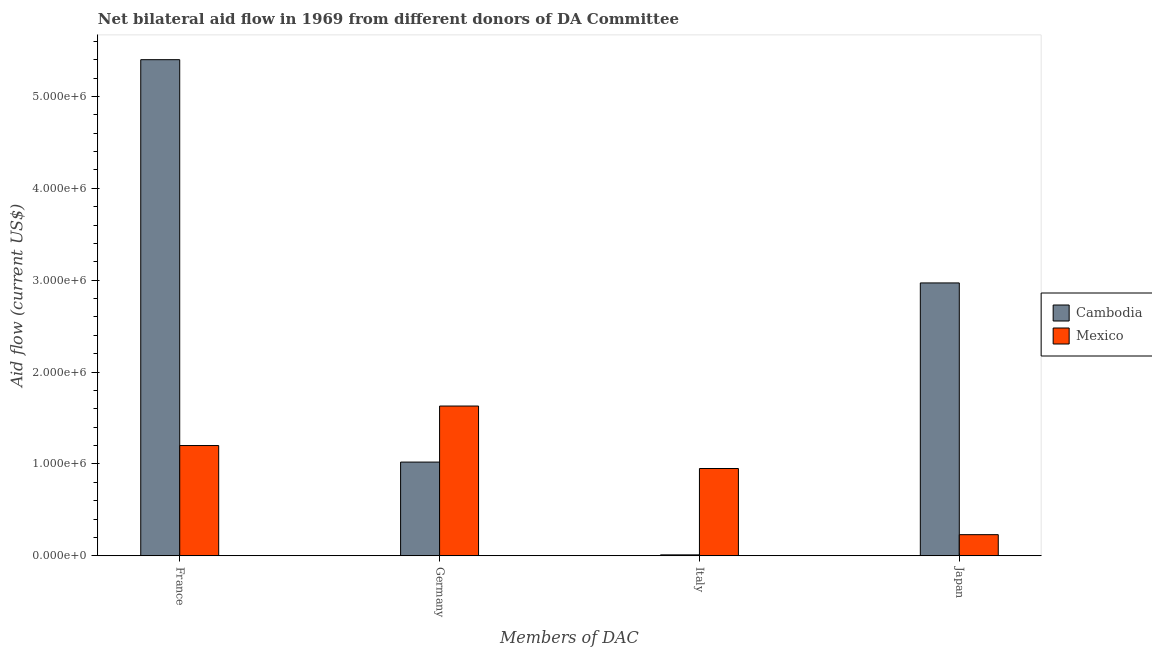How many different coloured bars are there?
Your answer should be very brief. 2. Are the number of bars per tick equal to the number of legend labels?
Provide a short and direct response. Yes. What is the label of the 2nd group of bars from the left?
Your response must be concise. Germany. What is the amount of aid given by france in Cambodia?
Provide a succinct answer. 5.40e+06. Across all countries, what is the maximum amount of aid given by germany?
Your answer should be very brief. 1.63e+06. Across all countries, what is the minimum amount of aid given by germany?
Your answer should be compact. 1.02e+06. In which country was the amount of aid given by france maximum?
Provide a succinct answer. Cambodia. What is the total amount of aid given by germany in the graph?
Give a very brief answer. 2.65e+06. What is the difference between the amount of aid given by italy in Cambodia and that in Mexico?
Your answer should be compact. -9.40e+05. What is the difference between the amount of aid given by france in Mexico and the amount of aid given by japan in Cambodia?
Offer a terse response. -1.77e+06. What is the difference between the amount of aid given by france and amount of aid given by italy in Cambodia?
Make the answer very short. 5.39e+06. What is the ratio of the amount of aid given by germany in Mexico to that in Cambodia?
Offer a terse response. 1.6. Is the difference between the amount of aid given by france in Cambodia and Mexico greater than the difference between the amount of aid given by japan in Cambodia and Mexico?
Your answer should be compact. Yes. What is the difference between the highest and the second highest amount of aid given by japan?
Give a very brief answer. 2.74e+06. What is the difference between the highest and the lowest amount of aid given by italy?
Your answer should be very brief. 9.40e+05. In how many countries, is the amount of aid given by japan greater than the average amount of aid given by japan taken over all countries?
Give a very brief answer. 1. Is it the case that in every country, the sum of the amount of aid given by italy and amount of aid given by germany is greater than the sum of amount of aid given by france and amount of aid given by japan?
Your answer should be very brief. No. What does the 2nd bar from the left in Japan represents?
Provide a short and direct response. Mexico. What does the 2nd bar from the right in Germany represents?
Provide a short and direct response. Cambodia. Are all the bars in the graph horizontal?
Your answer should be very brief. No. How many countries are there in the graph?
Give a very brief answer. 2. What is the difference between two consecutive major ticks on the Y-axis?
Offer a very short reply. 1.00e+06. Are the values on the major ticks of Y-axis written in scientific E-notation?
Your answer should be very brief. Yes. Where does the legend appear in the graph?
Provide a succinct answer. Center right. How many legend labels are there?
Provide a short and direct response. 2. What is the title of the graph?
Your answer should be very brief. Net bilateral aid flow in 1969 from different donors of DA Committee. Does "Sweden" appear as one of the legend labels in the graph?
Provide a short and direct response. No. What is the label or title of the X-axis?
Keep it short and to the point. Members of DAC. What is the label or title of the Y-axis?
Give a very brief answer. Aid flow (current US$). What is the Aid flow (current US$) in Cambodia in France?
Keep it short and to the point. 5.40e+06. What is the Aid flow (current US$) of Mexico in France?
Your answer should be very brief. 1.20e+06. What is the Aid flow (current US$) of Cambodia in Germany?
Give a very brief answer. 1.02e+06. What is the Aid flow (current US$) of Mexico in Germany?
Your response must be concise. 1.63e+06. What is the Aid flow (current US$) of Cambodia in Italy?
Ensure brevity in your answer.  10000. What is the Aid flow (current US$) of Mexico in Italy?
Offer a very short reply. 9.50e+05. What is the Aid flow (current US$) in Cambodia in Japan?
Provide a succinct answer. 2.97e+06. What is the Aid flow (current US$) of Mexico in Japan?
Ensure brevity in your answer.  2.30e+05. Across all Members of DAC, what is the maximum Aid flow (current US$) of Cambodia?
Keep it short and to the point. 5.40e+06. Across all Members of DAC, what is the maximum Aid flow (current US$) in Mexico?
Ensure brevity in your answer.  1.63e+06. Across all Members of DAC, what is the minimum Aid flow (current US$) in Cambodia?
Ensure brevity in your answer.  10000. What is the total Aid flow (current US$) in Cambodia in the graph?
Your answer should be very brief. 9.40e+06. What is the total Aid flow (current US$) of Mexico in the graph?
Offer a terse response. 4.01e+06. What is the difference between the Aid flow (current US$) of Cambodia in France and that in Germany?
Offer a very short reply. 4.38e+06. What is the difference between the Aid flow (current US$) in Mexico in France and that in Germany?
Offer a very short reply. -4.30e+05. What is the difference between the Aid flow (current US$) of Cambodia in France and that in Italy?
Your response must be concise. 5.39e+06. What is the difference between the Aid flow (current US$) in Cambodia in France and that in Japan?
Your answer should be very brief. 2.43e+06. What is the difference between the Aid flow (current US$) of Mexico in France and that in Japan?
Your answer should be very brief. 9.70e+05. What is the difference between the Aid flow (current US$) of Cambodia in Germany and that in Italy?
Provide a succinct answer. 1.01e+06. What is the difference between the Aid flow (current US$) in Mexico in Germany and that in Italy?
Your answer should be compact. 6.80e+05. What is the difference between the Aid flow (current US$) of Cambodia in Germany and that in Japan?
Ensure brevity in your answer.  -1.95e+06. What is the difference between the Aid flow (current US$) in Mexico in Germany and that in Japan?
Provide a succinct answer. 1.40e+06. What is the difference between the Aid flow (current US$) in Cambodia in Italy and that in Japan?
Offer a terse response. -2.96e+06. What is the difference between the Aid flow (current US$) in Mexico in Italy and that in Japan?
Offer a very short reply. 7.20e+05. What is the difference between the Aid flow (current US$) in Cambodia in France and the Aid flow (current US$) in Mexico in Germany?
Provide a short and direct response. 3.77e+06. What is the difference between the Aid flow (current US$) of Cambodia in France and the Aid flow (current US$) of Mexico in Italy?
Your answer should be very brief. 4.45e+06. What is the difference between the Aid flow (current US$) of Cambodia in France and the Aid flow (current US$) of Mexico in Japan?
Your answer should be compact. 5.17e+06. What is the difference between the Aid flow (current US$) in Cambodia in Germany and the Aid flow (current US$) in Mexico in Italy?
Offer a very short reply. 7.00e+04. What is the difference between the Aid flow (current US$) in Cambodia in Germany and the Aid flow (current US$) in Mexico in Japan?
Your answer should be compact. 7.90e+05. What is the average Aid flow (current US$) in Cambodia per Members of DAC?
Keep it short and to the point. 2.35e+06. What is the average Aid flow (current US$) in Mexico per Members of DAC?
Your answer should be very brief. 1.00e+06. What is the difference between the Aid flow (current US$) in Cambodia and Aid flow (current US$) in Mexico in France?
Ensure brevity in your answer.  4.20e+06. What is the difference between the Aid flow (current US$) in Cambodia and Aid flow (current US$) in Mexico in Germany?
Give a very brief answer. -6.10e+05. What is the difference between the Aid flow (current US$) of Cambodia and Aid flow (current US$) of Mexico in Italy?
Make the answer very short. -9.40e+05. What is the difference between the Aid flow (current US$) in Cambodia and Aid flow (current US$) in Mexico in Japan?
Your response must be concise. 2.74e+06. What is the ratio of the Aid flow (current US$) in Cambodia in France to that in Germany?
Your response must be concise. 5.29. What is the ratio of the Aid flow (current US$) in Mexico in France to that in Germany?
Your answer should be compact. 0.74. What is the ratio of the Aid flow (current US$) in Cambodia in France to that in Italy?
Your response must be concise. 540. What is the ratio of the Aid flow (current US$) of Mexico in France to that in Italy?
Provide a short and direct response. 1.26. What is the ratio of the Aid flow (current US$) in Cambodia in France to that in Japan?
Offer a terse response. 1.82. What is the ratio of the Aid flow (current US$) of Mexico in France to that in Japan?
Provide a short and direct response. 5.22. What is the ratio of the Aid flow (current US$) of Cambodia in Germany to that in Italy?
Your answer should be very brief. 102. What is the ratio of the Aid flow (current US$) in Mexico in Germany to that in Italy?
Offer a very short reply. 1.72. What is the ratio of the Aid flow (current US$) of Cambodia in Germany to that in Japan?
Your answer should be very brief. 0.34. What is the ratio of the Aid flow (current US$) in Mexico in Germany to that in Japan?
Your answer should be very brief. 7.09. What is the ratio of the Aid flow (current US$) of Cambodia in Italy to that in Japan?
Your answer should be very brief. 0. What is the ratio of the Aid flow (current US$) in Mexico in Italy to that in Japan?
Provide a succinct answer. 4.13. What is the difference between the highest and the second highest Aid flow (current US$) in Cambodia?
Your response must be concise. 2.43e+06. What is the difference between the highest and the second highest Aid flow (current US$) in Mexico?
Provide a succinct answer. 4.30e+05. What is the difference between the highest and the lowest Aid flow (current US$) of Cambodia?
Provide a succinct answer. 5.39e+06. What is the difference between the highest and the lowest Aid flow (current US$) in Mexico?
Ensure brevity in your answer.  1.40e+06. 